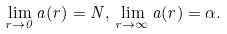<formula> <loc_0><loc_0><loc_500><loc_500>\lim _ { r \rightarrow 0 } a ( r ) = N , \, \lim _ { r \rightarrow \infty } a ( r ) = \alpha .</formula> 